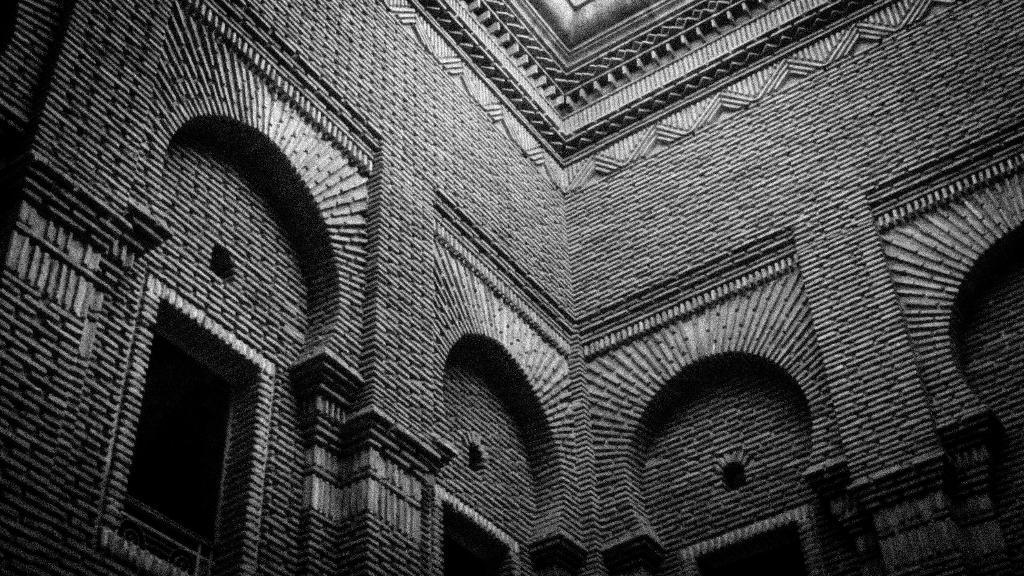What is the color scheme of the image? The image is black and white. What type of scene is depicted in the image? The image shows an inner view of a building. What architectural features can be seen in the building? There are windows and a roof visible in the building. What type of account does the duck have at the club in the image? There is no duck or club present in the image; it shows an inner view of a building with windows and a roof. 